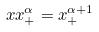Convert formula to latex. <formula><loc_0><loc_0><loc_500><loc_500>x x _ { + } ^ { \alpha } = x _ { + } ^ { \alpha + 1 }</formula> 